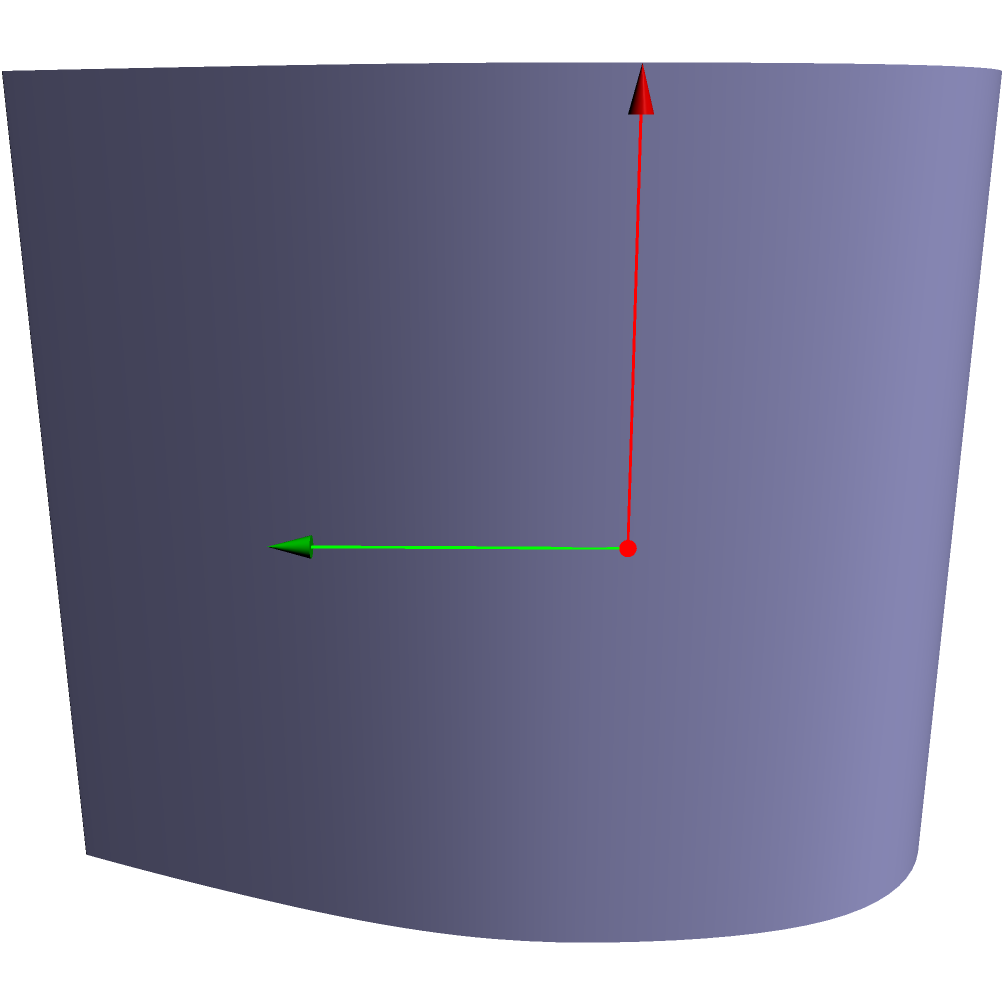In engraving a consistent depth line on a curved firearm surface, you need to find the perpendicular vector to both the surface normal and the engraving direction. Given a cylindrical surface with radius 2 and the point of engraving at $(2\cos(\frac{\pi}{4}), 2\sin(\frac{\pi}{4}), 1)$, if the engraving direction is parallel to the z-axis $(0,0,1)$, what is the perpendicular vector that will maintain a consistent engraving depth? To find the perpendicular vector for consistent engraving depth, we need to follow these steps:

1) Identify the surface normal vector at the given point:
   The normal vector to a cylinder at any point is perpendicular to the z-axis and points outward from the center. At the given point, this is:
   $\vec{n} = (-\cos(\frac{\pi}{4}), -\sin(\frac{\pi}{4}), 0)$

2) Identify the engraving direction vector:
   Given as $\vec{v} = (0, 0, 1)$

3) To find the perpendicular vector, we use the cross product of these two vectors:
   $\vec{perp} = \vec{v} \times \vec{n}$

4) Calculate the cross product:
   $\vec{perp} = (0,0,1) \times (-\cos(\frac{\pi}{4}), -\sin(\frac{\pi}{4}), 0)$
   $= (\sin(\frac{\pi}{4}), -\cos(\frac{\pi}{4}), 0)$

5) Simplify using $\cos(\frac{\pi}{4}) = \sin(\frac{\pi}{4}) = \frac{1}{\sqrt{2}}$:
   $\vec{perp} = (\frac{1}{\sqrt{2}}, -\frac{1}{\sqrt{2}}, 0)$

This vector is perpendicular to both the surface normal and the engraving direction, ensuring a consistent depth across the curved surface.
Answer: $(\frac{1}{\sqrt{2}}, -\frac{1}{\sqrt{2}}, 0)$ 